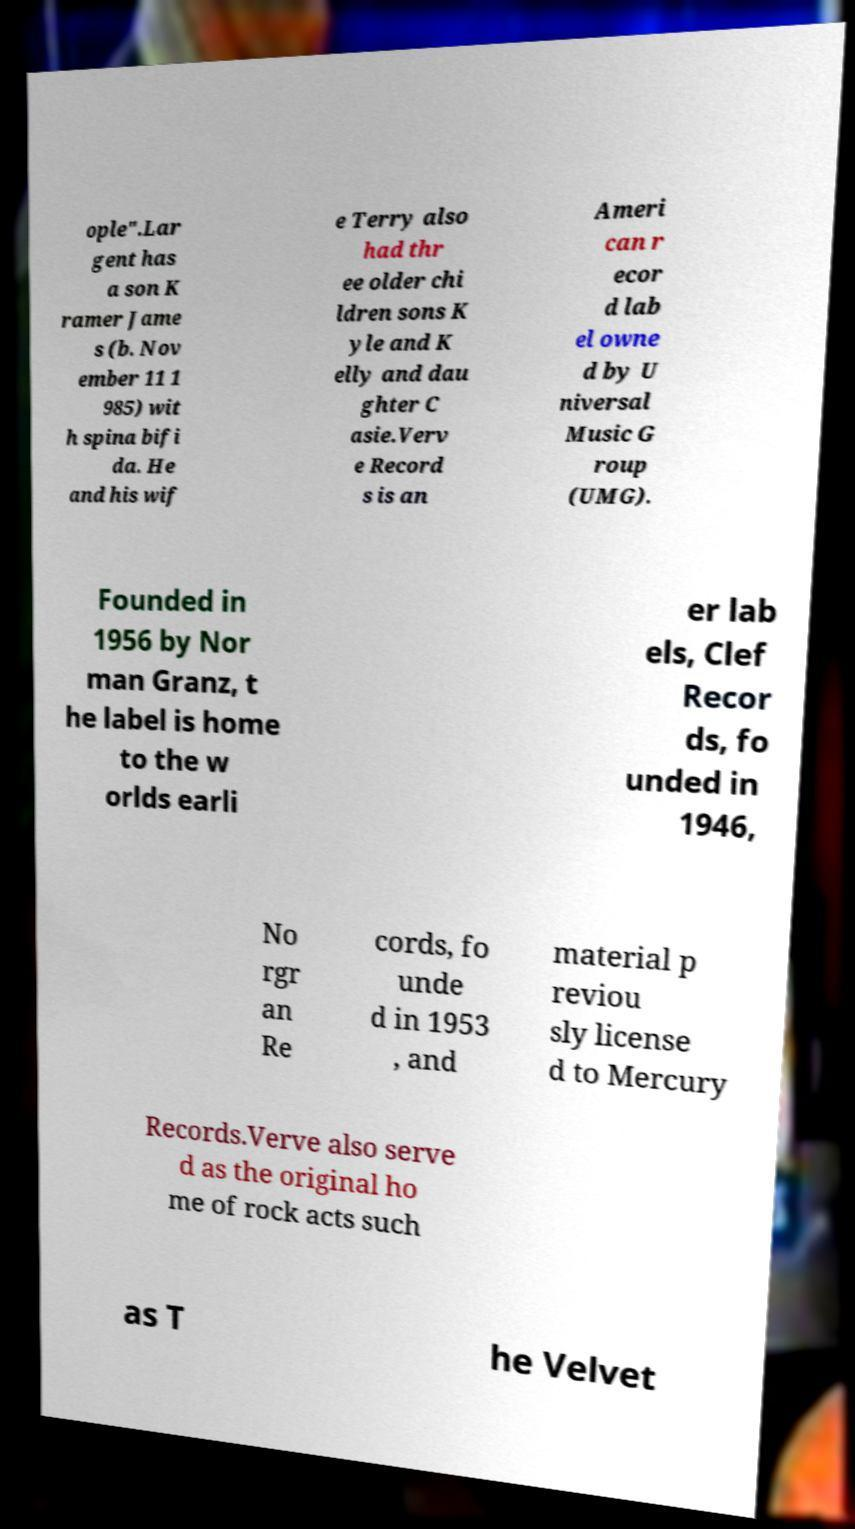There's text embedded in this image that I need extracted. Can you transcribe it verbatim? ople".Lar gent has a son K ramer Jame s (b. Nov ember 11 1 985) wit h spina bifi da. He and his wif e Terry also had thr ee older chi ldren sons K yle and K elly and dau ghter C asie.Verv e Record s is an Ameri can r ecor d lab el owne d by U niversal Music G roup (UMG). Founded in 1956 by Nor man Granz, t he label is home to the w orlds earli er lab els, Clef Recor ds, fo unded in 1946, No rgr an Re cords, fo unde d in 1953 , and material p reviou sly license d to Mercury Records.Verve also serve d as the original ho me of rock acts such as T he Velvet 